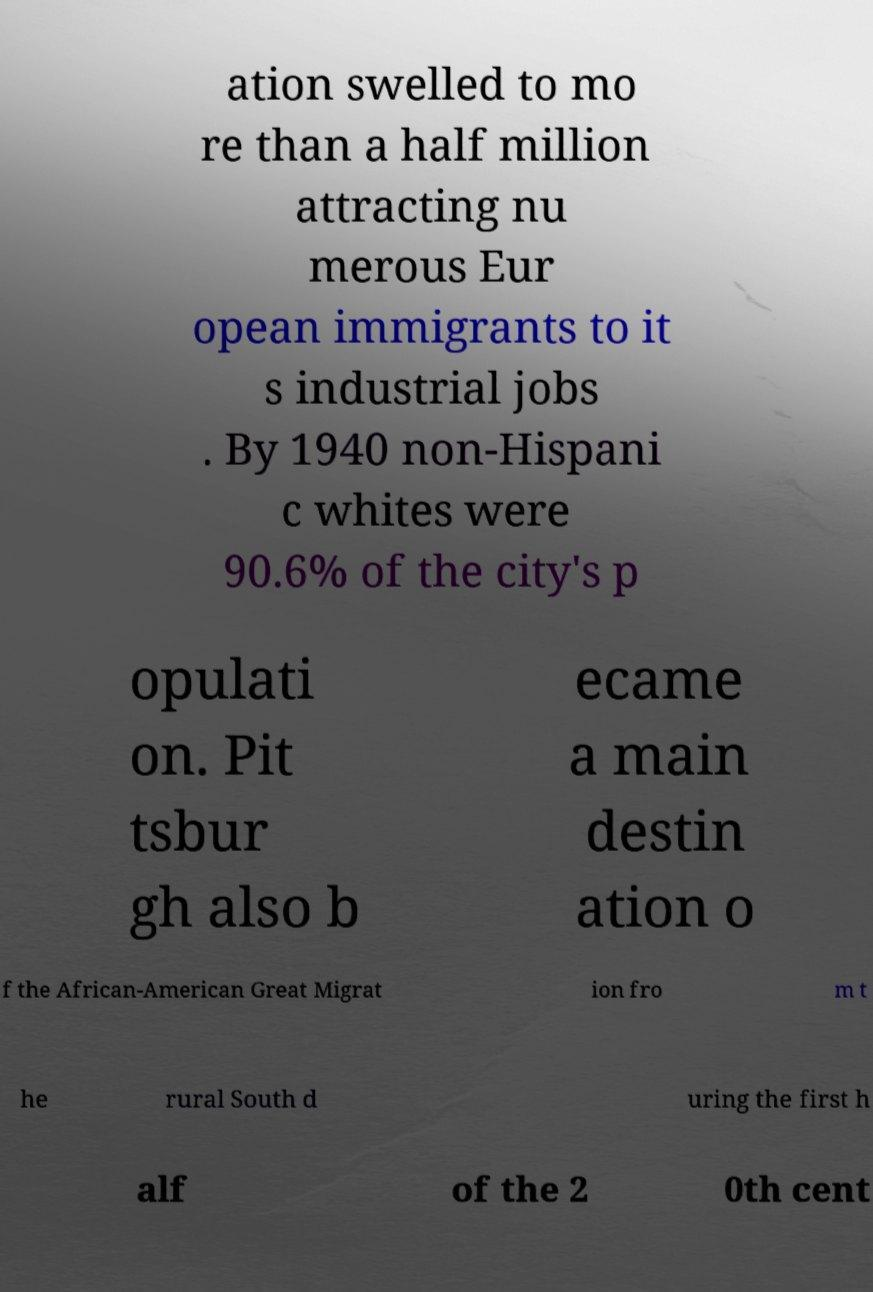For documentation purposes, I need the text within this image transcribed. Could you provide that? ation swelled to mo re than a half million attracting nu merous Eur opean immigrants to it s industrial jobs . By 1940 non-Hispani c whites were 90.6% of the city's p opulati on. Pit tsbur gh also b ecame a main destin ation o f the African-American Great Migrat ion fro m t he rural South d uring the first h alf of the 2 0th cent 